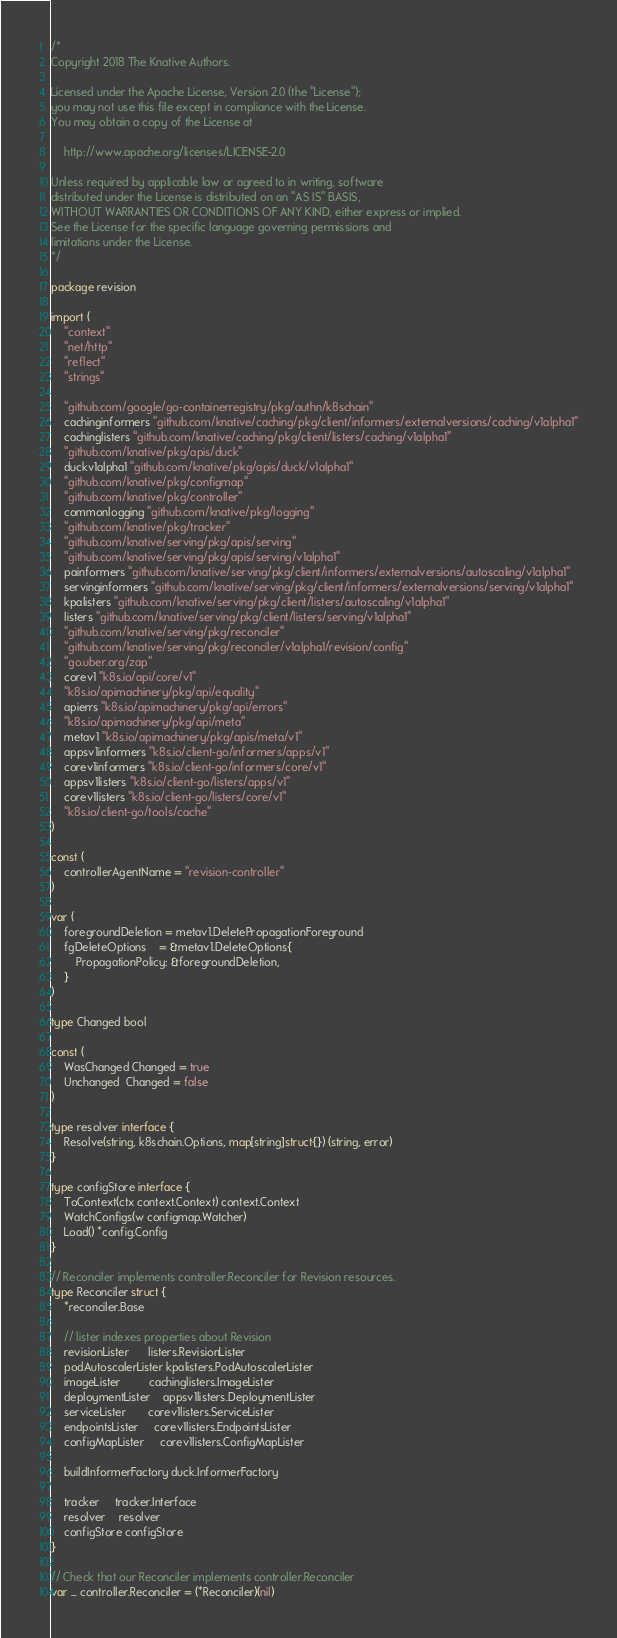Convert code to text. <code><loc_0><loc_0><loc_500><loc_500><_Go_>/*
Copyright 2018 The Knative Authors.

Licensed under the Apache License, Version 2.0 (the "License");
you may not use this file except in compliance with the License.
You may obtain a copy of the License at

    http://www.apache.org/licenses/LICENSE-2.0

Unless required by applicable law or agreed to in writing, software
distributed under the License is distributed on an "AS IS" BASIS,
WITHOUT WARRANTIES OR CONDITIONS OF ANY KIND, either express or implied.
See the License for the specific language governing permissions and
limitations under the License.
*/

package revision

import (
	"context"
	"net/http"
	"reflect"
	"strings"

	"github.com/google/go-containerregistry/pkg/authn/k8schain"
	cachinginformers "github.com/knative/caching/pkg/client/informers/externalversions/caching/v1alpha1"
	cachinglisters "github.com/knative/caching/pkg/client/listers/caching/v1alpha1"
	"github.com/knative/pkg/apis/duck"
	duckv1alpha1 "github.com/knative/pkg/apis/duck/v1alpha1"
	"github.com/knative/pkg/configmap"
	"github.com/knative/pkg/controller"
	commonlogging "github.com/knative/pkg/logging"
	"github.com/knative/pkg/tracker"
	"github.com/knative/serving/pkg/apis/serving"
	"github.com/knative/serving/pkg/apis/serving/v1alpha1"
	painformers "github.com/knative/serving/pkg/client/informers/externalversions/autoscaling/v1alpha1"
	servinginformers "github.com/knative/serving/pkg/client/informers/externalversions/serving/v1alpha1"
	kpalisters "github.com/knative/serving/pkg/client/listers/autoscaling/v1alpha1"
	listers "github.com/knative/serving/pkg/client/listers/serving/v1alpha1"
	"github.com/knative/serving/pkg/reconciler"
	"github.com/knative/serving/pkg/reconciler/v1alpha1/revision/config"
	"go.uber.org/zap"
	corev1 "k8s.io/api/core/v1"
	"k8s.io/apimachinery/pkg/api/equality"
	apierrs "k8s.io/apimachinery/pkg/api/errors"
	"k8s.io/apimachinery/pkg/api/meta"
	metav1 "k8s.io/apimachinery/pkg/apis/meta/v1"
	appsv1informers "k8s.io/client-go/informers/apps/v1"
	corev1informers "k8s.io/client-go/informers/core/v1"
	appsv1listers "k8s.io/client-go/listers/apps/v1"
	corev1listers "k8s.io/client-go/listers/core/v1"
	"k8s.io/client-go/tools/cache"
)

const (
	controllerAgentName = "revision-controller"
)

var (
	foregroundDeletion = metav1.DeletePropagationForeground
	fgDeleteOptions    = &metav1.DeleteOptions{
		PropagationPolicy: &foregroundDeletion,
	}
)

type Changed bool

const (
	WasChanged Changed = true
	Unchanged  Changed = false
)

type resolver interface {
	Resolve(string, k8schain.Options, map[string]struct{}) (string, error)
}

type configStore interface {
	ToContext(ctx context.Context) context.Context
	WatchConfigs(w configmap.Watcher)
	Load() *config.Config
}

// Reconciler implements controller.Reconciler for Revision resources.
type Reconciler struct {
	*reconciler.Base

	// lister indexes properties about Revision
	revisionLister      listers.RevisionLister
	podAutoscalerLister kpalisters.PodAutoscalerLister
	imageLister         cachinglisters.ImageLister
	deploymentLister    appsv1listers.DeploymentLister
	serviceLister       corev1listers.ServiceLister
	endpointsLister     corev1listers.EndpointsLister
	configMapLister     corev1listers.ConfigMapLister

	buildInformerFactory duck.InformerFactory

	tracker     tracker.Interface
	resolver    resolver
	configStore configStore
}

// Check that our Reconciler implements controller.Reconciler
var _ controller.Reconciler = (*Reconciler)(nil)
</code> 